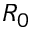Convert formula to latex. <formula><loc_0><loc_0><loc_500><loc_500>R _ { 0 }</formula> 